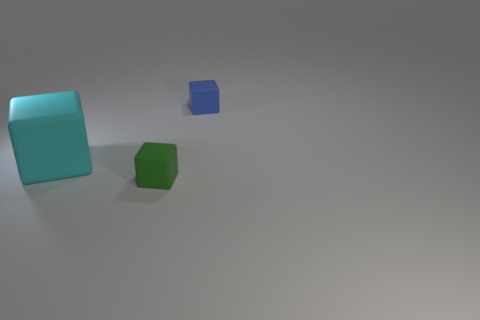Subtract all tiny blocks. How many blocks are left? 1 Add 2 tiny green rubber cubes. How many objects exist? 5 Add 2 tiny blue rubber things. How many tiny blue rubber things are left? 3 Add 3 cyan objects. How many cyan objects exist? 4 Subtract 0 yellow cylinders. How many objects are left? 3 Subtract all yellow rubber cubes. Subtract all rubber cubes. How many objects are left? 0 